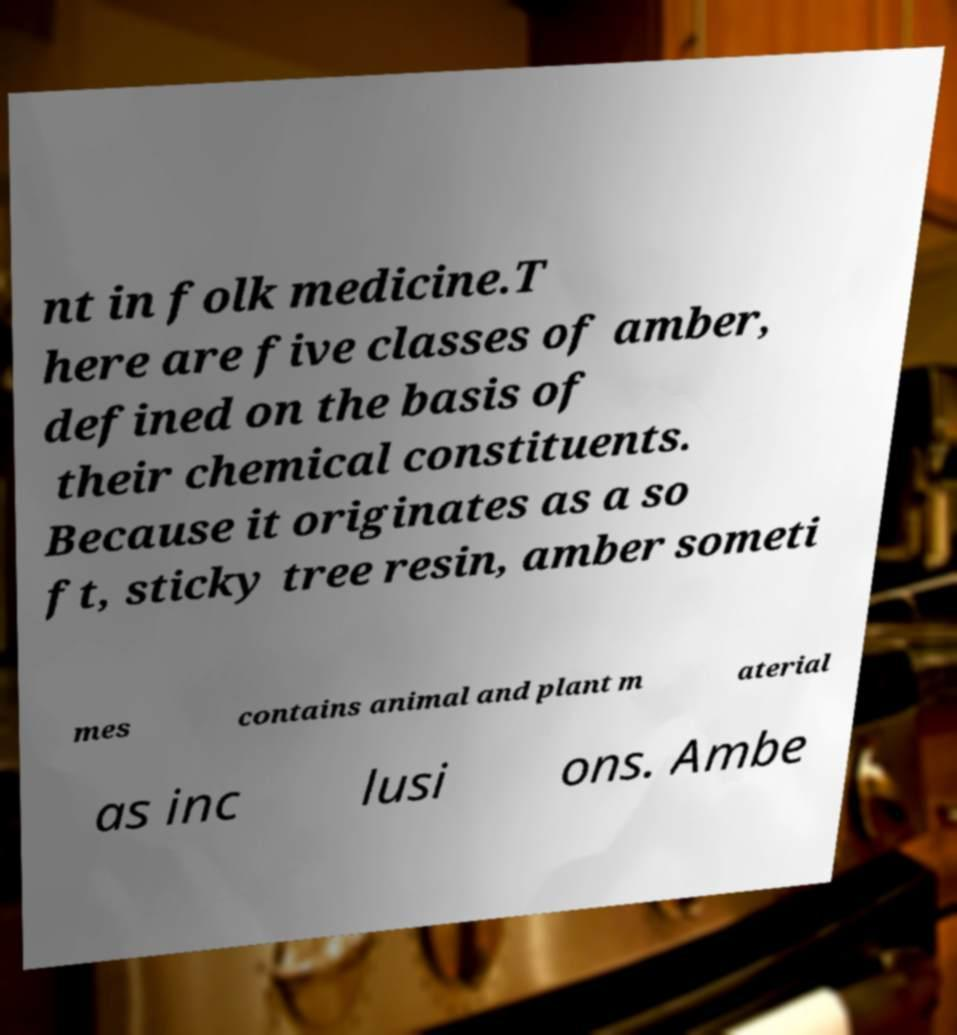There's text embedded in this image that I need extracted. Can you transcribe it verbatim? nt in folk medicine.T here are five classes of amber, defined on the basis of their chemical constituents. Because it originates as a so ft, sticky tree resin, amber someti mes contains animal and plant m aterial as inc lusi ons. Ambe 